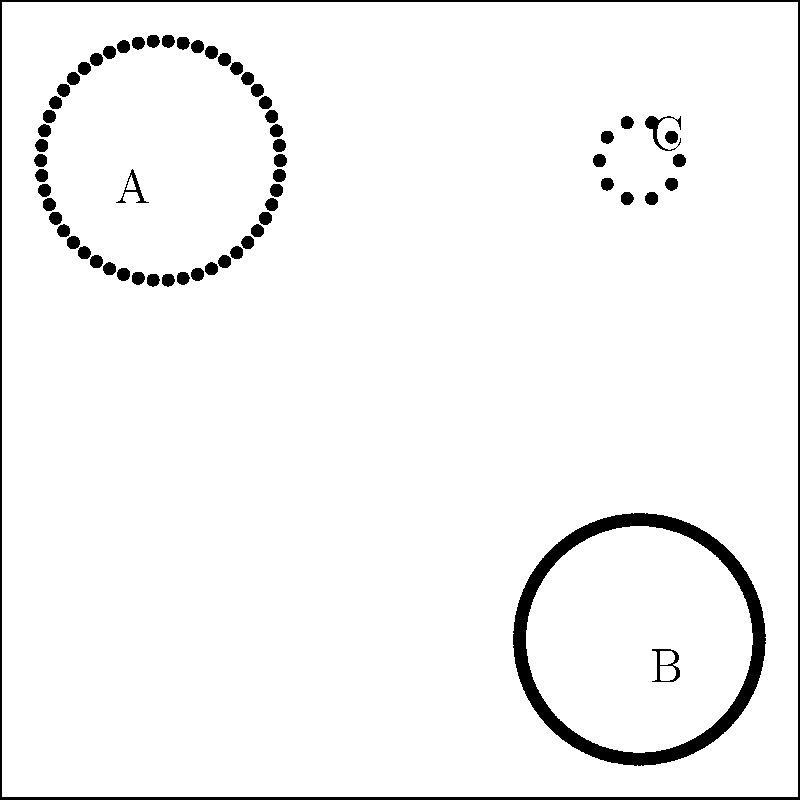As an artist exploring celestial aesthetics, which of the star cluster representations (A, B, or C) would you consider the most visually striking for an avant-garde installation piece focusing on the concept of "cosmic density"? To answer this question, we need to analyze the aesthetic qualities of each star cluster representation and how they relate to the concept of "cosmic density":

1. Cluster A:
   - Moderate number of stars (about 50)
   - Spread out evenly in a circular pattern
   - Creates a sense of balance and order

2. Cluster B:
   - High number of stars (about 200)
   - Densely packed in a circular pattern
   - Creates a sense of fullness and intensity

3. Cluster C:
   - Low number of stars (about 10)
   - Spread out in a small, tight cluster
   - Creates a sense of isolation and intimacy

Considering the concept of "cosmic density," we should focus on which representation best conveys the idea of concentrated matter in space. 

Cluster B stands out as the most visually striking for this purpose because:
1. It has the highest number of stars, representing a dense collection of celestial objects.
2. The stars are tightly packed, emphasizing the concept of density.
3. The large number of points creates a visually complex and captivating image, which aligns with avant-garde artistic sensibilities.

While Clusters A and C have their own aesthetic merits, they don't convey the same sense of density and cosmic abundance that Cluster B does. Cluster A is too evenly spread out, and Cluster C has too few stars to effectively represent "cosmic density."

For an avant-garde installation piece, Cluster B would provide the most impactful visual representation of dense cosmic structures, allowing viewers to experience the awe-inspiring nature of crowded star fields and galactic cores.
Answer: Cluster B 